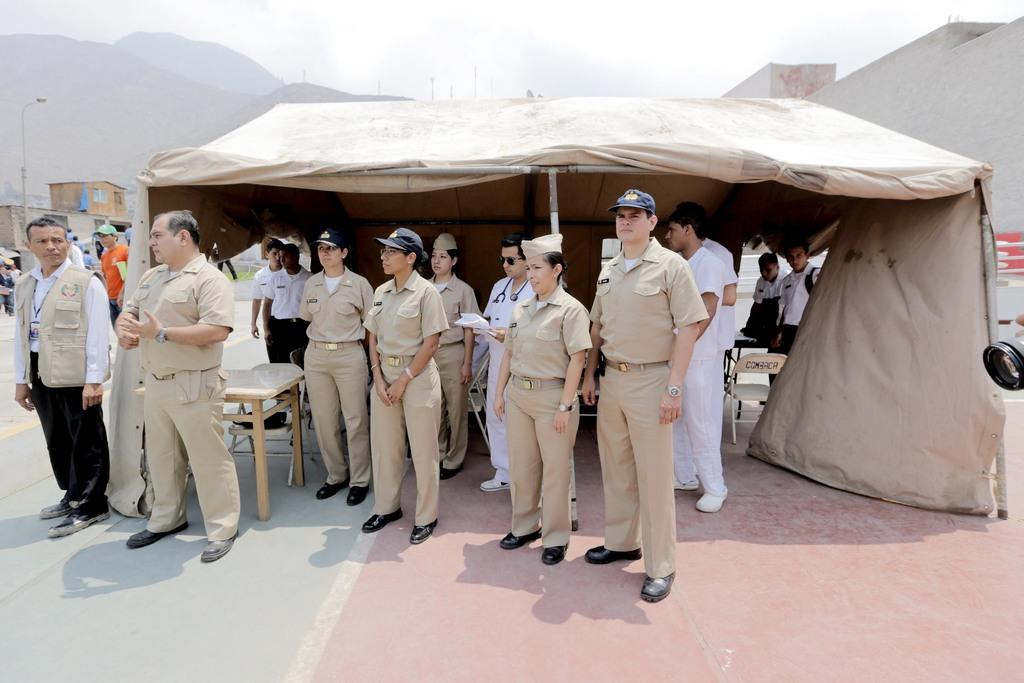What type of people can be seen in the image? There are policemen and women in the image. Where are the policemen and women positioned in the image? The policemen and women are standing in the front. What can be seen in the background of the image? There is a tent house and mountains visible in the background of the image. What type of cord is being used by the insect in the image? There is no insect or cord present in the image. How many brothers are visible in the image? There are no brothers visible in the image; it features policemen and women. 